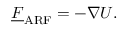Convert formula to latex. <formula><loc_0><loc_0><loc_500><loc_500>\underline { F } _ { A R F } = - \nabla U .</formula> 